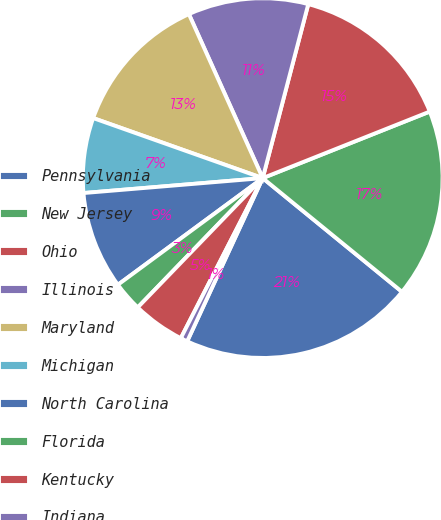Convert chart. <chart><loc_0><loc_0><loc_500><loc_500><pie_chart><fcel>Pennsylvania<fcel>New Jersey<fcel>Ohio<fcel>Illinois<fcel>Maryland<fcel>Michigan<fcel>North Carolina<fcel>Florida<fcel>Kentucky<fcel>Indiana<nl><fcel>21.0%<fcel>16.93%<fcel>14.89%<fcel>10.81%<fcel>12.85%<fcel>6.74%<fcel>8.78%<fcel>2.67%<fcel>4.7%<fcel>0.63%<nl></chart> 